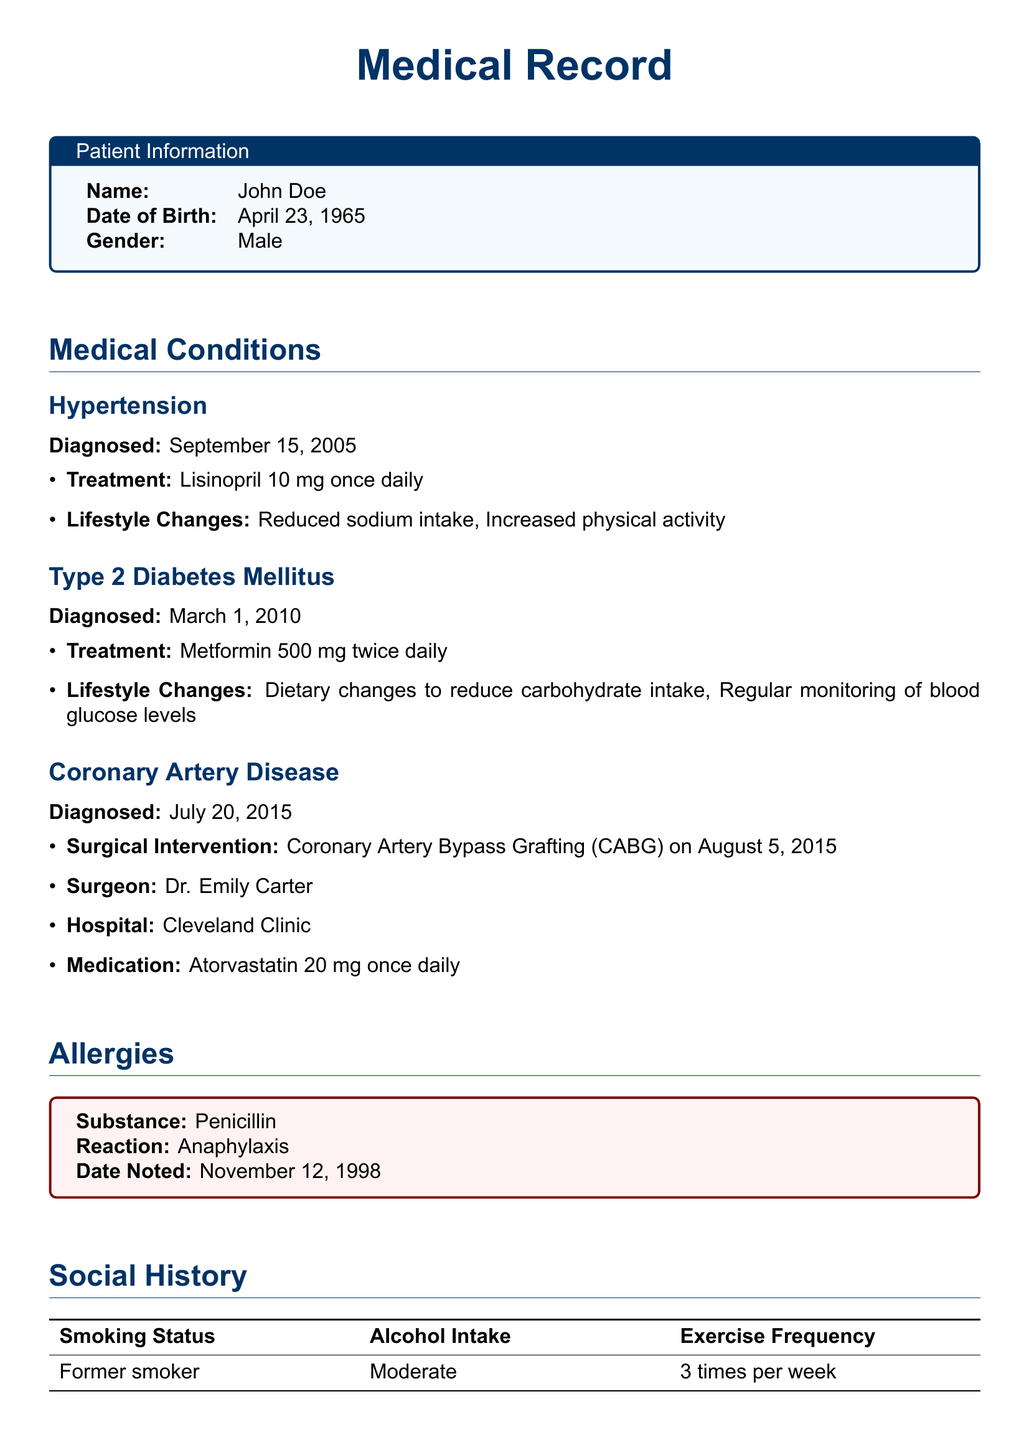What is the patient's name? The patient's name is listed at the top of the document.
Answer: John Doe When was the patient diagnosed with hypertension? The date of diagnosis for hypertension is indicated under the medical conditions section.
Answer: September 15, 2005 What treatment is prescribed for Type 2 Diabetes Mellitus? The treatment listed for Type 2 Diabetes Mellitus is found in the corresponding subsection.
Answer: Metformin 500 mg twice daily What surgical intervention did the patient undergo? The document specifies a surgical procedure performed on the patient under the Coronary Artery Disease section.
Answer: Coronary Artery Bypass Grafting (CABG) Who was the surgeon for the CABG? The surgeon's name is mentioned alongside the surgical intervention details.
Answer: Dr. Emily Carter What is the patient's smoking status? This information is found in the social history section of the document.
Answer: Former smoker What allergy does the patient have? The document lists the substance that the patient is allergic to in the allergies section.
Answer: Penicillin What family health condition does the patient's mother have? This information is included in the family history section of the document.
Answer: Breast Cancer How often does the patient exercise? The exercise frequency is provided in the social history section.
Answer: 3 times per week 